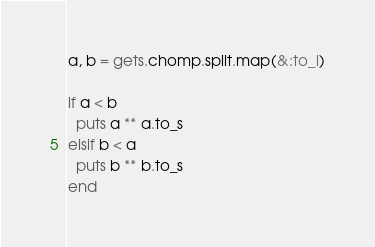Convert code to text. <code><loc_0><loc_0><loc_500><loc_500><_Ruby_>a, b = gets.chomp.split.map(&:to_i)

if a < b
  puts a ** a.to_s
elsif b < a
  puts b ** b.to_s
end
</code> 